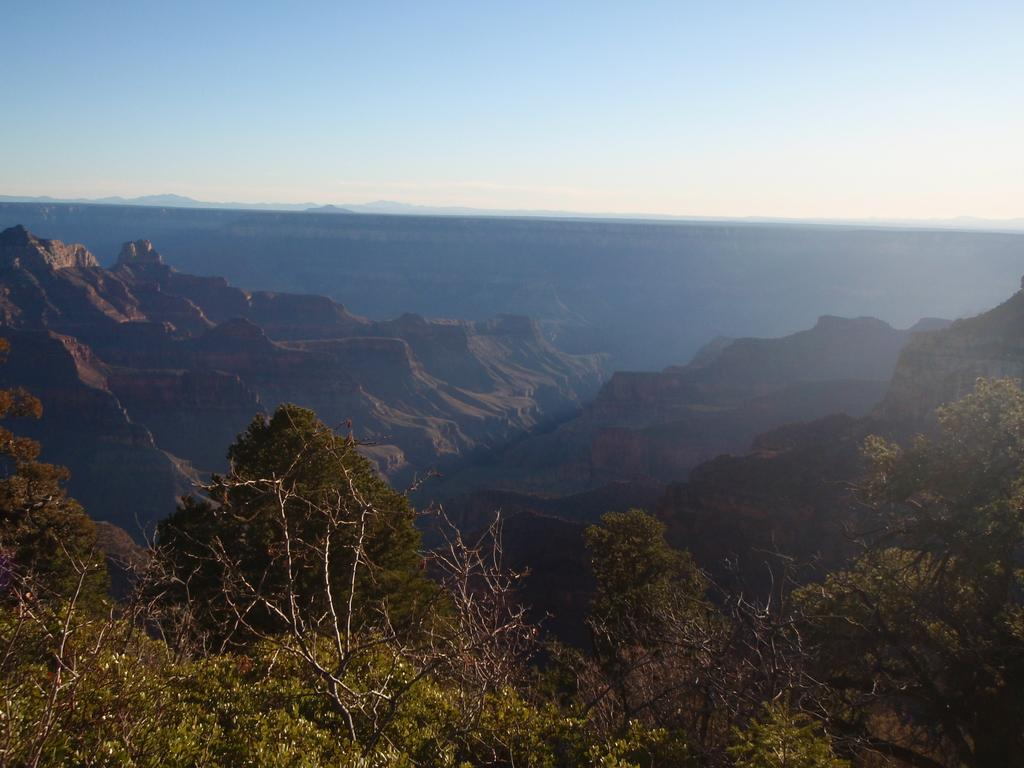What is visible in the center of the image? The sky, hills, and trees are visible in the center of the image. Can you describe the trees in the image? The trees in the image have branches and leaves. What type of vegetation is present in the image? Trees are present in the image. What type of cable can be seen connecting the trees in the image? There is no cable connecting the trees in the image; only the trees, hills, and sky are present. What type of authority is depicted in the image? There is no authority figure depicted in the image; it features natural elements such as trees, hills, and the sky. 